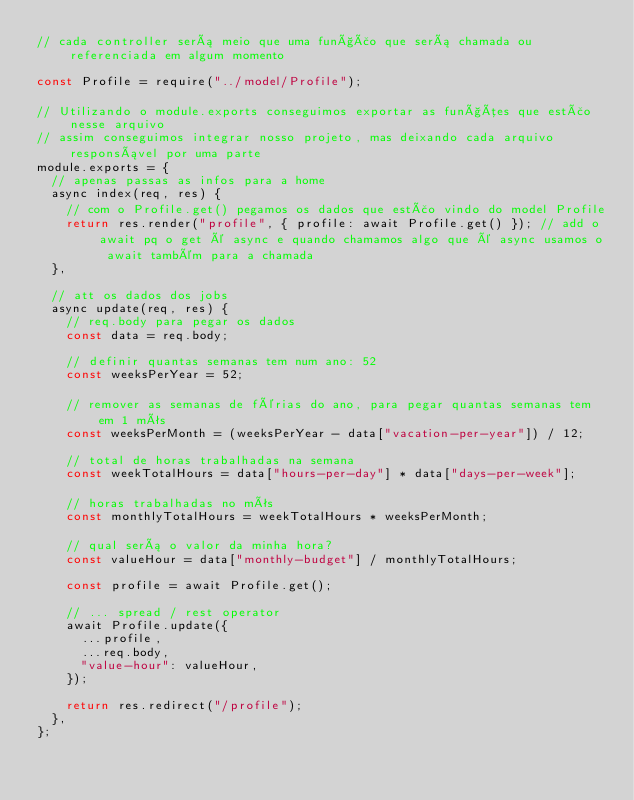<code> <loc_0><loc_0><loc_500><loc_500><_JavaScript_>// cada controller será meio que uma função que será chamada ou referenciada em algum momento

const Profile = require("../model/Profile");

// Utilizando o module.exports conseguimos exportar as funções que estão nesse arquivo
// assim conseguimos integrar nosso projeto, mas deixando cada arquivo responsável por uma parte
module.exports = {
  // apenas passas as infos para a home
  async index(req, res) {
    // com o Profile.get() pegamos os dados que estão vindo do model Profile
    return res.render("profile", { profile: await Profile.get() }); // add o await pq o get é async e quando chamamos algo que é async usamos o await também para a chamada
  },

  // att os dados dos jobs
  async update(req, res) {
    // req.body para pegar os dados
    const data = req.body;

    // definir quantas semanas tem num ano: 52
    const weeksPerYear = 52;

    // remover as semanas de férias do ano, para pegar quantas semanas tem em 1 mês
    const weeksPerMonth = (weeksPerYear - data["vacation-per-year"]) / 12;

    // total de horas trabalhadas na semana
    const weekTotalHours = data["hours-per-day"] * data["days-per-week"];

    // horas trabalhadas no mês
    const monthlyTotalHours = weekTotalHours * weeksPerMonth;

    // qual será o valor da minha hora?
    const valueHour = data["monthly-budget"] / monthlyTotalHours;

    const profile = await Profile.get();

    // ... spread / rest operator
    await Profile.update({
      ...profile,
      ...req.body,
      "value-hour": valueHour,
    });

    return res.redirect("/profile");
  },
};
</code> 